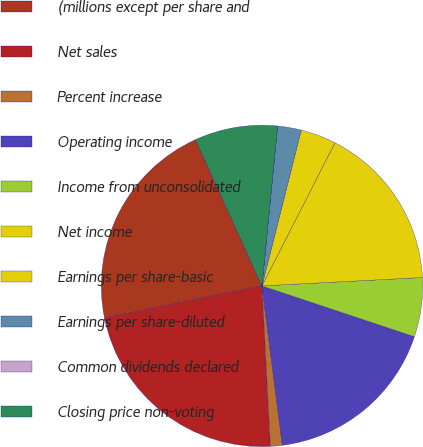Convert chart to OTSL. <chart><loc_0><loc_0><loc_500><loc_500><pie_chart><fcel>(millions except per share and<fcel>Net sales<fcel>Percent increase<fcel>Operating income<fcel>Income from unconsolidated<fcel>Net income<fcel>Earnings per share-basic<fcel>Earnings per share-diluted<fcel>Common dividends declared<fcel>Closing price non-voting<nl><fcel>21.42%<fcel>22.61%<fcel>1.19%<fcel>17.85%<fcel>5.95%<fcel>16.66%<fcel>3.57%<fcel>2.38%<fcel>0.0%<fcel>8.33%<nl></chart> 